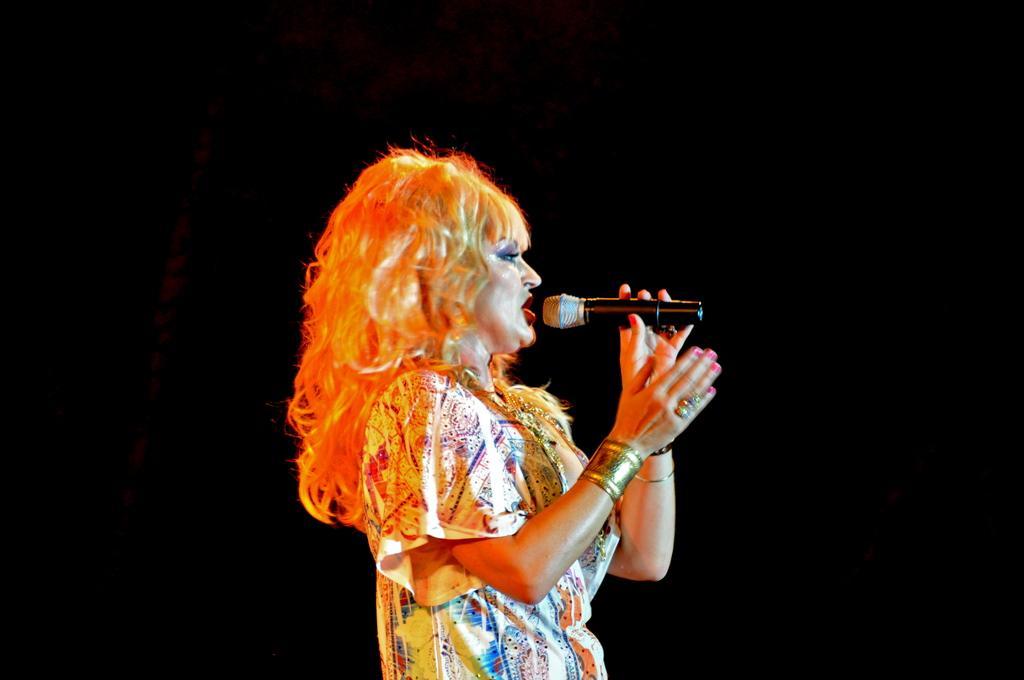Describe this image in one or two sentences. This woman is holding mic and singing. Background is in black color. 